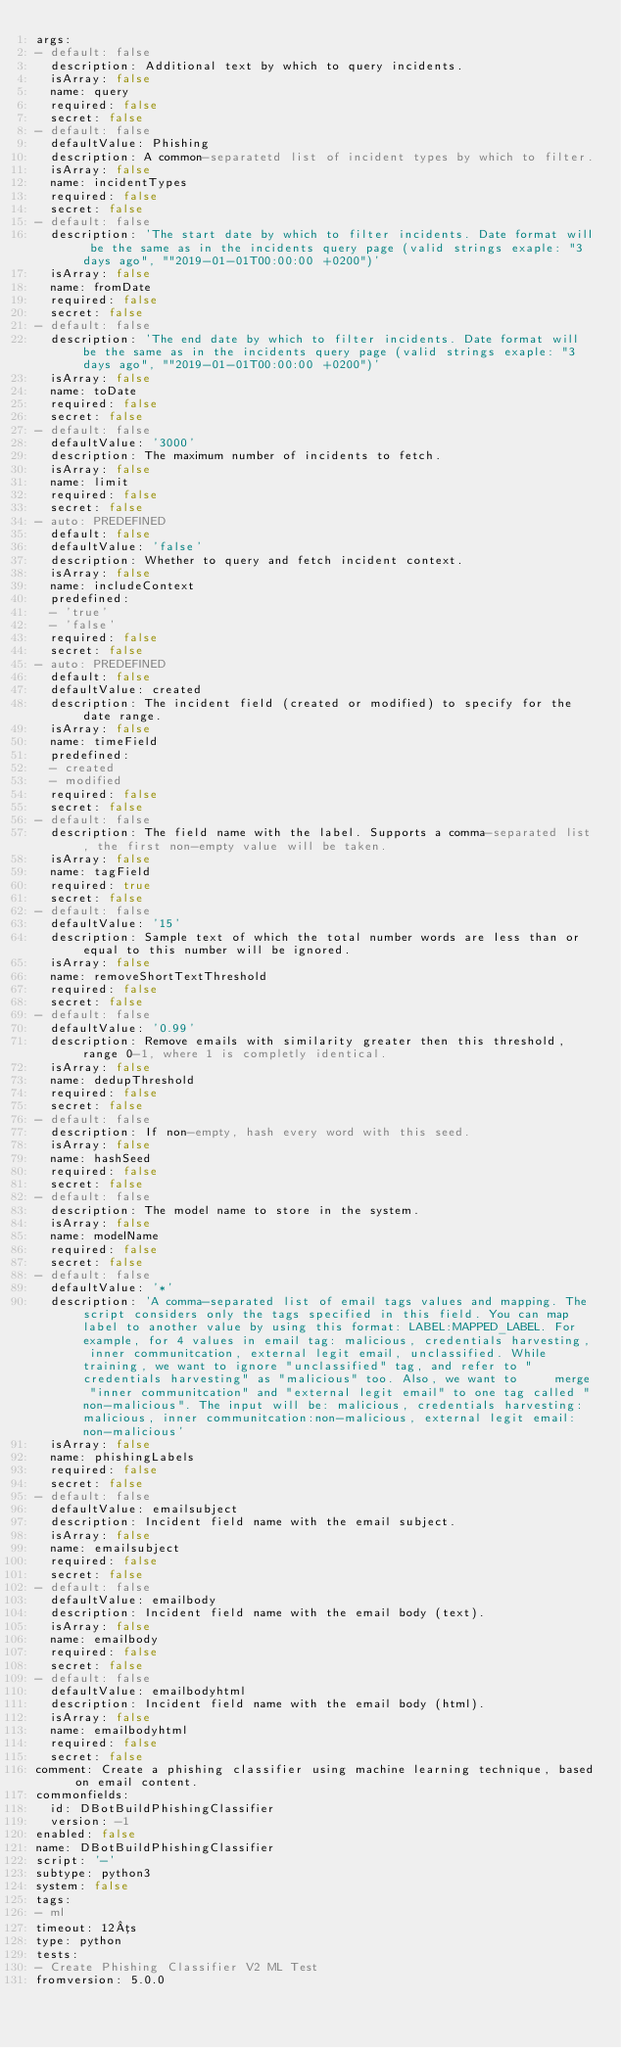<code> <loc_0><loc_0><loc_500><loc_500><_YAML_>args:
- default: false
  description: Additional text by which to query incidents.
  isArray: false
  name: query
  required: false
  secret: false
- default: false
  defaultValue: Phishing
  description: A common-separatetd list of incident types by which to filter.
  isArray: false
  name: incidentTypes
  required: false
  secret: false
- default: false
  description: 'The start date by which to filter incidents. Date format will be the same as in the incidents query page (valid strings exaple: "3 days ago", ""2019-01-01T00:00:00 +0200")'
  isArray: false
  name: fromDate
  required: false
  secret: false
- default: false
  description: 'The end date by which to filter incidents. Date format will be the same as in the incidents query page (valid strings exaple: "3 days ago", ""2019-01-01T00:00:00 +0200")'
  isArray: false
  name: toDate
  required: false
  secret: false
- default: false
  defaultValue: '3000'
  description: The maximum number of incidents to fetch.
  isArray: false
  name: limit
  required: false
  secret: false
- auto: PREDEFINED
  default: false
  defaultValue: 'false'
  description: Whether to query and fetch incident context.
  isArray: false
  name: includeContext
  predefined:
  - 'true'
  - 'false'
  required: false
  secret: false
- auto: PREDEFINED
  default: false
  defaultValue: created
  description: The incident field (created or modified) to specify for the date range.
  isArray: false
  name: timeField
  predefined:
  - created
  - modified
  required: false
  secret: false
- default: false
  description: The field name with the label. Supports a comma-separated list, the first non-empty value will be taken.
  isArray: false
  name: tagField
  required: true
  secret: false
- default: false
  defaultValue: '15'
  description: Sample text of which the total number words are less than or equal to this number will be ignored.
  isArray: false
  name: removeShortTextThreshold
  required: false
  secret: false
- default: false
  defaultValue: '0.99'
  description: Remove emails with similarity greater then this threshold, range 0-1, where 1 is completly identical.
  isArray: false
  name: dedupThreshold
  required: false
  secret: false
- default: false
  description: If non-empty, hash every word with this seed.
  isArray: false
  name: hashSeed
  required: false
  secret: false
- default: false
  description: The model name to store in the system.
  isArray: false
  name: modelName
  required: false
  secret: false
- default: false
  defaultValue: '*'
  description: 'A comma-separated list of email tags values and mapping. The script considers only the tags specified in this field. You can map label to another value by using this format: LABEL:MAPPED_LABEL. For example, for 4 values in email tag: malicious, credentials harvesting, inner communitcation, external legit email, unclassified. While training, we want to ignore "unclassified" tag, and refer to "credentials harvesting" as "malicious" too. Also, we want to     merge "inner communitcation" and "external legit email" to one tag called "non-malicious". The input will be: malicious, credentials harvesting:malicious, inner communitcation:non-malicious, external legit email:non-malicious'
  isArray: false
  name: phishingLabels
  required: false
  secret: false
- default: false
  defaultValue: emailsubject
  description: Incident field name with the email subject.
  isArray: false
  name: emailsubject
  required: false
  secret: false
- default: false
  defaultValue: emailbody
  description: Incident field name with the email body (text).
  isArray: false
  name: emailbody
  required: false
  secret: false
- default: false
  defaultValue: emailbodyhtml
  description: Incident field name with the email body (html).
  isArray: false
  name: emailbodyhtml
  required: false
  secret: false
comment: Create a phishing classifier using machine learning technique, based on email content.
commonfields:
  id: DBotBuildPhishingClassifier
  version: -1
enabled: false
name: DBotBuildPhishingClassifier
script: '-'
subtype: python3
system: false
tags:
- ml
timeout: 12µs
type: python
tests:
- Create Phishing Classifier V2 ML Test
fromversion: 5.0.0
</code> 